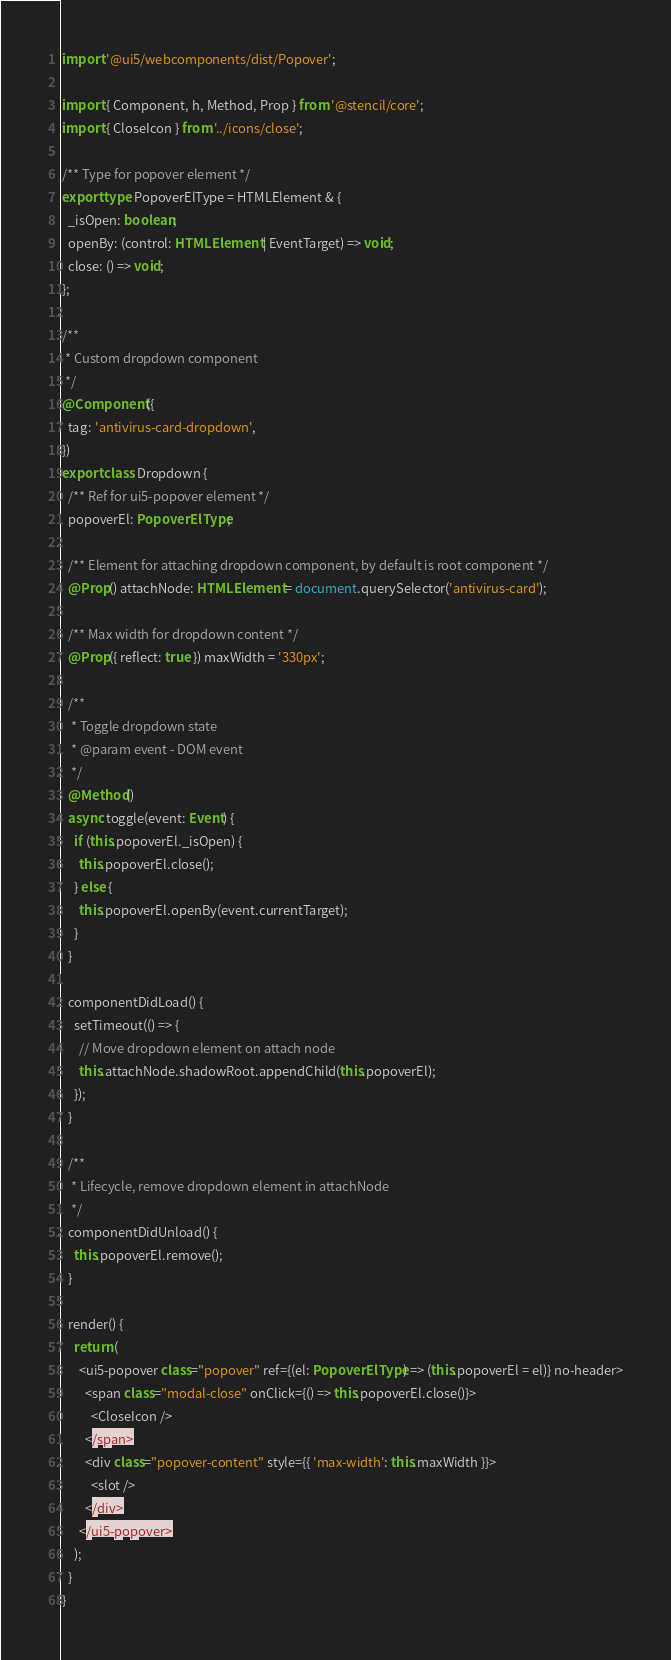Convert code to text. <code><loc_0><loc_0><loc_500><loc_500><_TypeScript_>import '@ui5/webcomponents/dist/Popover';

import { Component, h, Method, Prop } from '@stencil/core';
import { CloseIcon } from '../icons/close';

/** Type for popover element */
export type PopoverElType = HTMLElement & {
  _isOpen: boolean;
  openBy: (control: HTMLElement | EventTarget) => void;
  close: () => void;
};

/**
 * Custom dropdown component
 */
@Component({
  tag: 'antivirus-card-dropdown',
})
export class Dropdown {
  /** Ref for ui5-popover element */
  popoverEl: PopoverElType;

  /** Element for attaching dropdown component, by default is root component */
  @Prop() attachNode: HTMLElement = document.querySelector('antivirus-card');

  /** Max width for dropdown content */
  @Prop({ reflect: true }) maxWidth = '330px';

  /**
   * Toggle dropdown state
   * @param event - DOM event
   */
  @Method()
  async toggle(event: Event) {
    if (this.popoverEl._isOpen) {
      this.popoverEl.close();
    } else {
      this.popoverEl.openBy(event.currentTarget);
    }
  }

  componentDidLoad() {
    setTimeout(() => {
      // Move dropdown element on attach node
      this.attachNode.shadowRoot.appendChild(this.popoverEl);
    });
  }

  /**
   * Lifecycle, remove dropdown element in attachNode
   */
  componentDidUnload() {
    this.popoverEl.remove();
  }

  render() {
    return (
      <ui5-popover class="popover" ref={(el: PopoverElType) => (this.popoverEl = el)} no-header>
        <span class="modal-close" onClick={() => this.popoverEl.close()}>
          <CloseIcon />
        </span>
        <div class="popover-content" style={{ 'max-width': this.maxWidth }}>
          <slot />
        </div>
      </ui5-popover>
    );
  }
}
</code> 